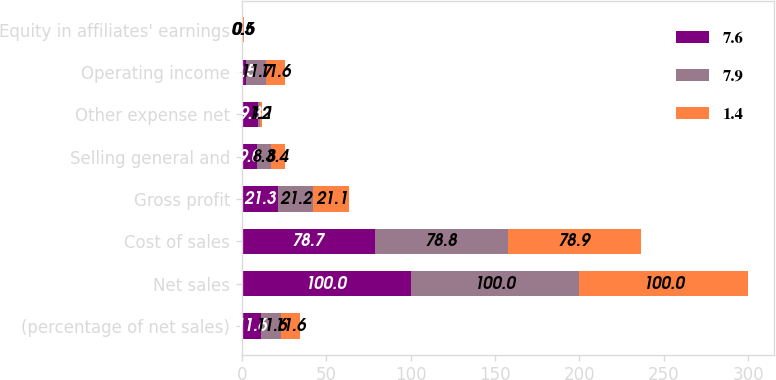Convert chart. <chart><loc_0><loc_0><loc_500><loc_500><stacked_bar_chart><ecel><fcel>(percentage of net sales)<fcel>Net sales<fcel>Cost of sales<fcel>Gross profit<fcel>Selling general and<fcel>Other expense net<fcel>Operating income<fcel>Equity in affiliates' earnings<nl><fcel>7.6<fcel>11.6<fcel>100<fcel>78.7<fcel>21.3<fcel>9<fcel>9.8<fcel>2.5<fcel>0.5<nl><fcel>7.9<fcel>11.6<fcel>100<fcel>78.8<fcel>21.2<fcel>8.3<fcel>1.2<fcel>11.7<fcel>0.5<nl><fcel>1.4<fcel>11.6<fcel>100<fcel>78.9<fcel>21.1<fcel>8.4<fcel>1.1<fcel>11.6<fcel>0.6<nl></chart> 